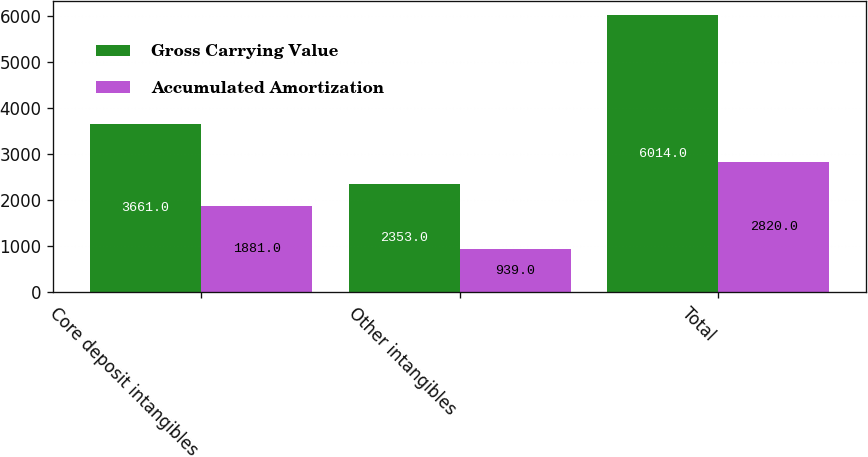<chart> <loc_0><loc_0><loc_500><loc_500><stacked_bar_chart><ecel><fcel>Core deposit intangibles<fcel>Other intangibles<fcel>Total<nl><fcel>Gross Carrying Value<fcel>3661<fcel>2353<fcel>6014<nl><fcel>Accumulated Amortization<fcel>1881<fcel>939<fcel>2820<nl></chart> 